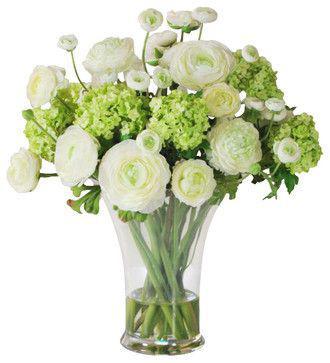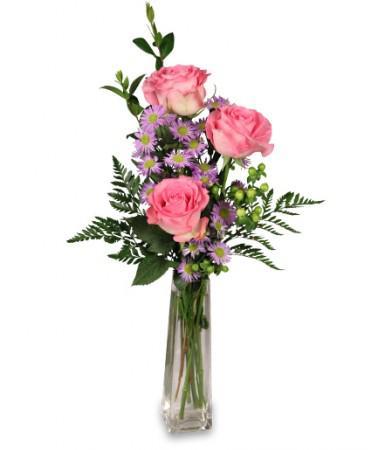The first image is the image on the left, the second image is the image on the right. Analyze the images presented: Is the assertion "One of the images contains white flowers" valid? Answer yes or no. Yes. 